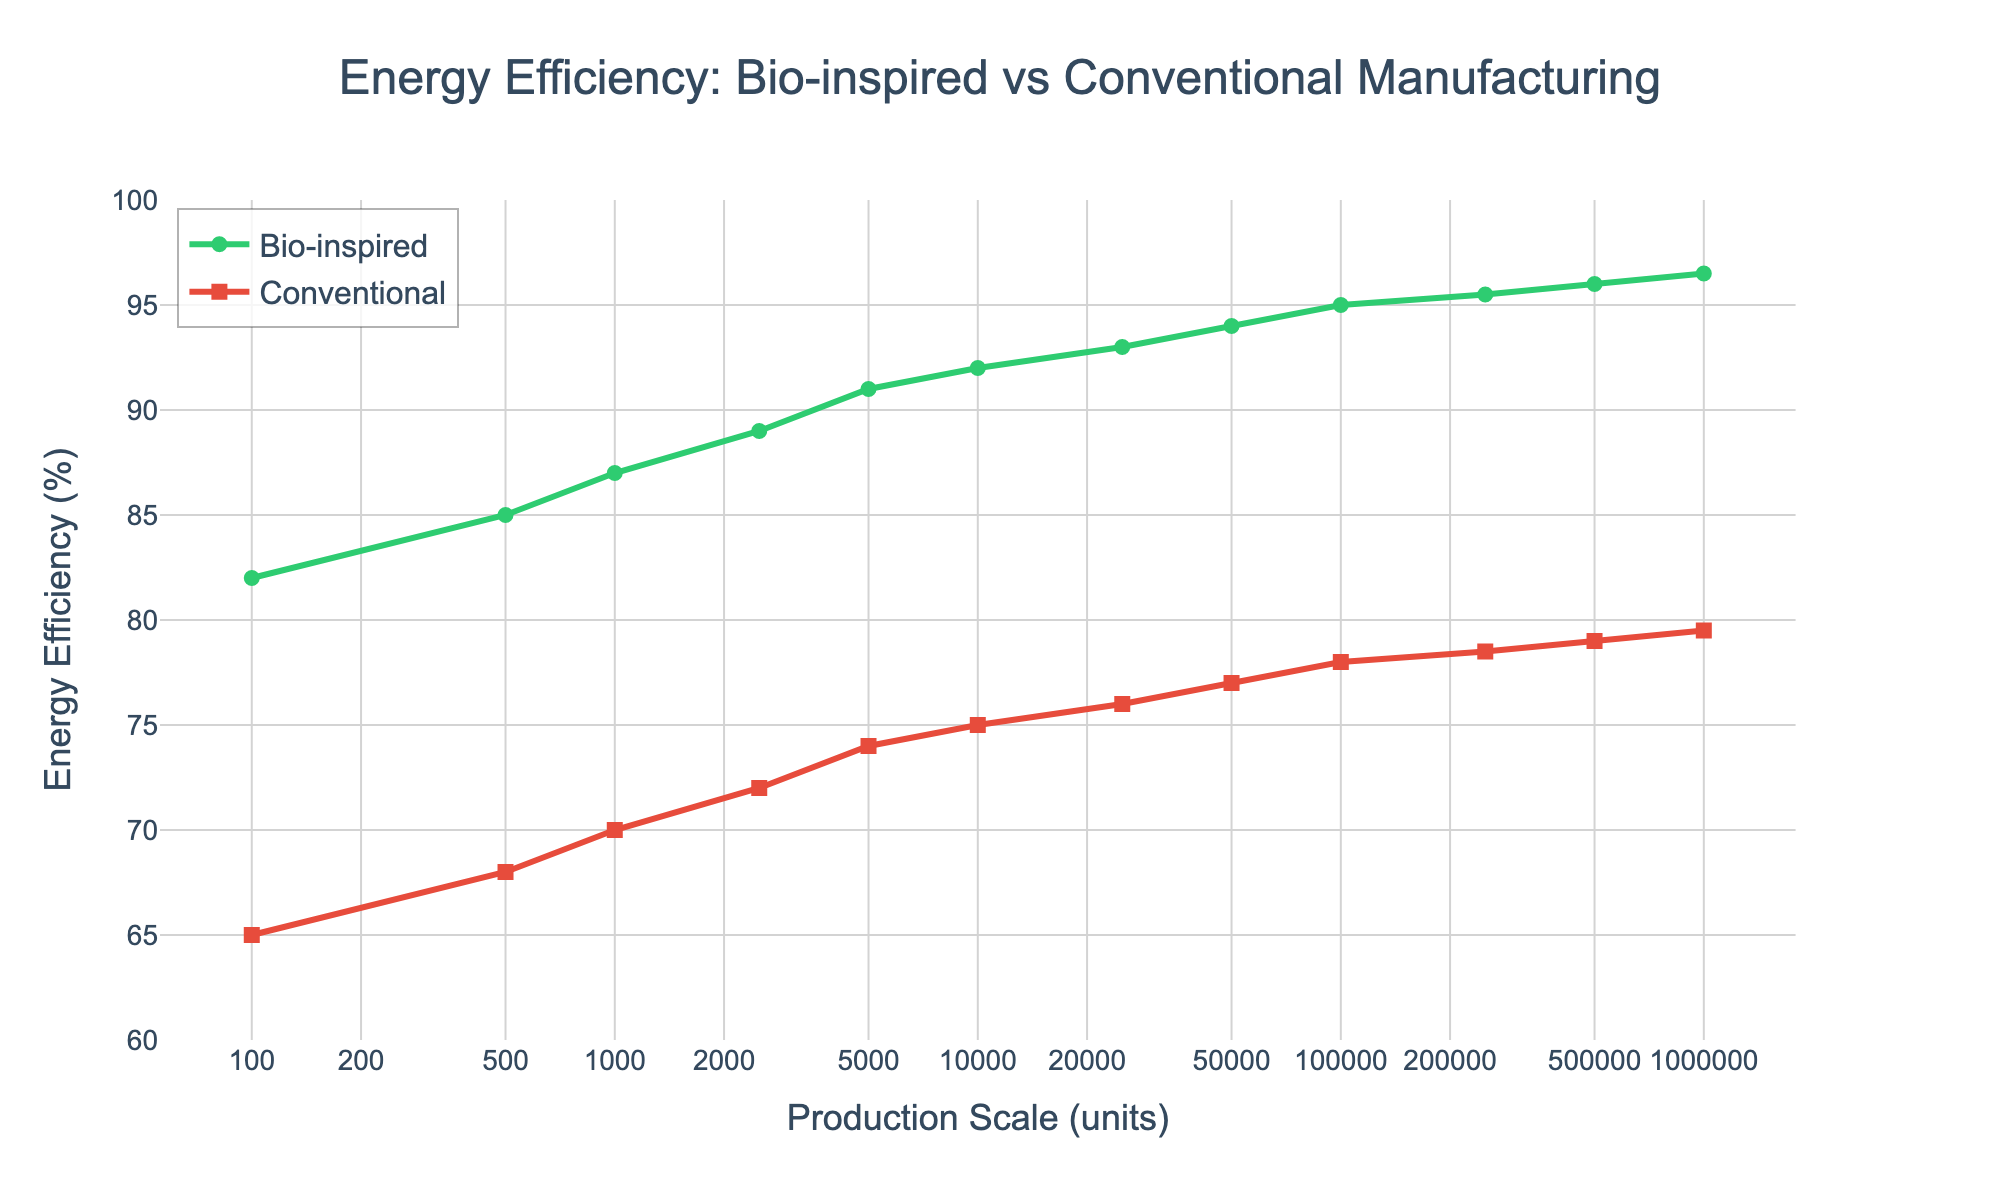What is the energy efficiency of bio-inspired manufacturing at a production scale of 250,000 units? Refer to the plot and locate the point representing 250,000 units on the x-axis. The corresponding y-value for the green line (bio-inspired) is 95.5%.
Answer: 95.5% Which method shows a higher energy efficiency at 1,000,000 production units? Locate 1,000,000 units on the x-axis and compare the efficiencies represented by the green (bio-inspired) and red (conventional) lines. The bio-inspired method has an efficiency of 96.5%, while the conventional method has 79.5%, so bio-inspired is higher.
Answer: Bio-inspired What is the difference in energy efficiency between bio-inspired and conventional methods at 10,000 units? Find the efficiencies at 10,000 units for both methods on the plot. Bio-inspired is at 92%, and conventional is at 75%. Calculate the difference: 92% - 75% = 17%.
Answer: 17% What is the general trend of energy efficiency for bio-inspired methods as the production scale increases? Observe the green line representing bio-inspired energy efficiency. As the production scale increases from 100 to 1,000,000 units, the efficiency consistently rises.
Answer: Increases At what production scale do both bio-inspired and conventional methods achieve a minimum of 90% energy efficiency? Look at the point where the green line (bio-inspired) first reaches 90% efficiency and the red line (conventional) first reaches approximately 90%. Bio-inspired reaches it at around 5,000 units, while conventional never does in the given data.
Answer: Bio-inspired: 5,000 units, Conventional: Never Which efficiency method sees a more significant increase from 100 to 1,000,000 units? Compare the starting and ending efficiencies for both methods. Bio-inspired goes from 82% to 96.5%, an increase of 14.5%. Conventional goes from 65% to 79.5%, an increase of 14.5%. Both methods have a 14.5% increase.
Answer: Both equally What is the average energy efficiency of bio-inspired manufacturing across all production scales shown in the chart? Sum the bio-inspired efficiency values and divide by the number of data points: (82+85+87+89+91+92+93+94+95+95.5+96+96.5)/12 = 92.5%
Answer: 92.5% At a production scale of 500 units, how much more energy-efficient is the bio-inspired method compared to the conventional method? Locate 500 units on the x-axis and compare the efficiencies. Bio-inspired is at 85%, and conventional is at 68%. The difference is 85% - 68% = 17%.
Answer: 17% Which production scale shows the least difference in energy efficiency between bio-inspired and conventional methods? Check the differences at each production scale by subtracting conventional efficiencies from bio-inspired efficiencies: smallest difference is at 450,000 units with 0.5%.
Answer: 250,000 units 